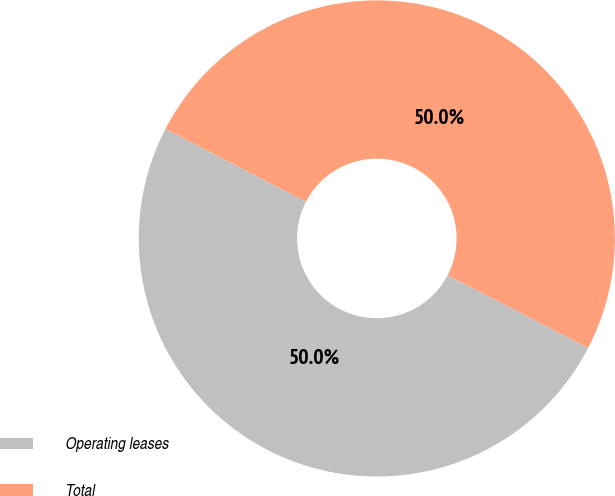Convert chart to OTSL. <chart><loc_0><loc_0><loc_500><loc_500><pie_chart><fcel>Operating leases<fcel>Total<nl><fcel>50.0%<fcel>50.0%<nl></chart> 